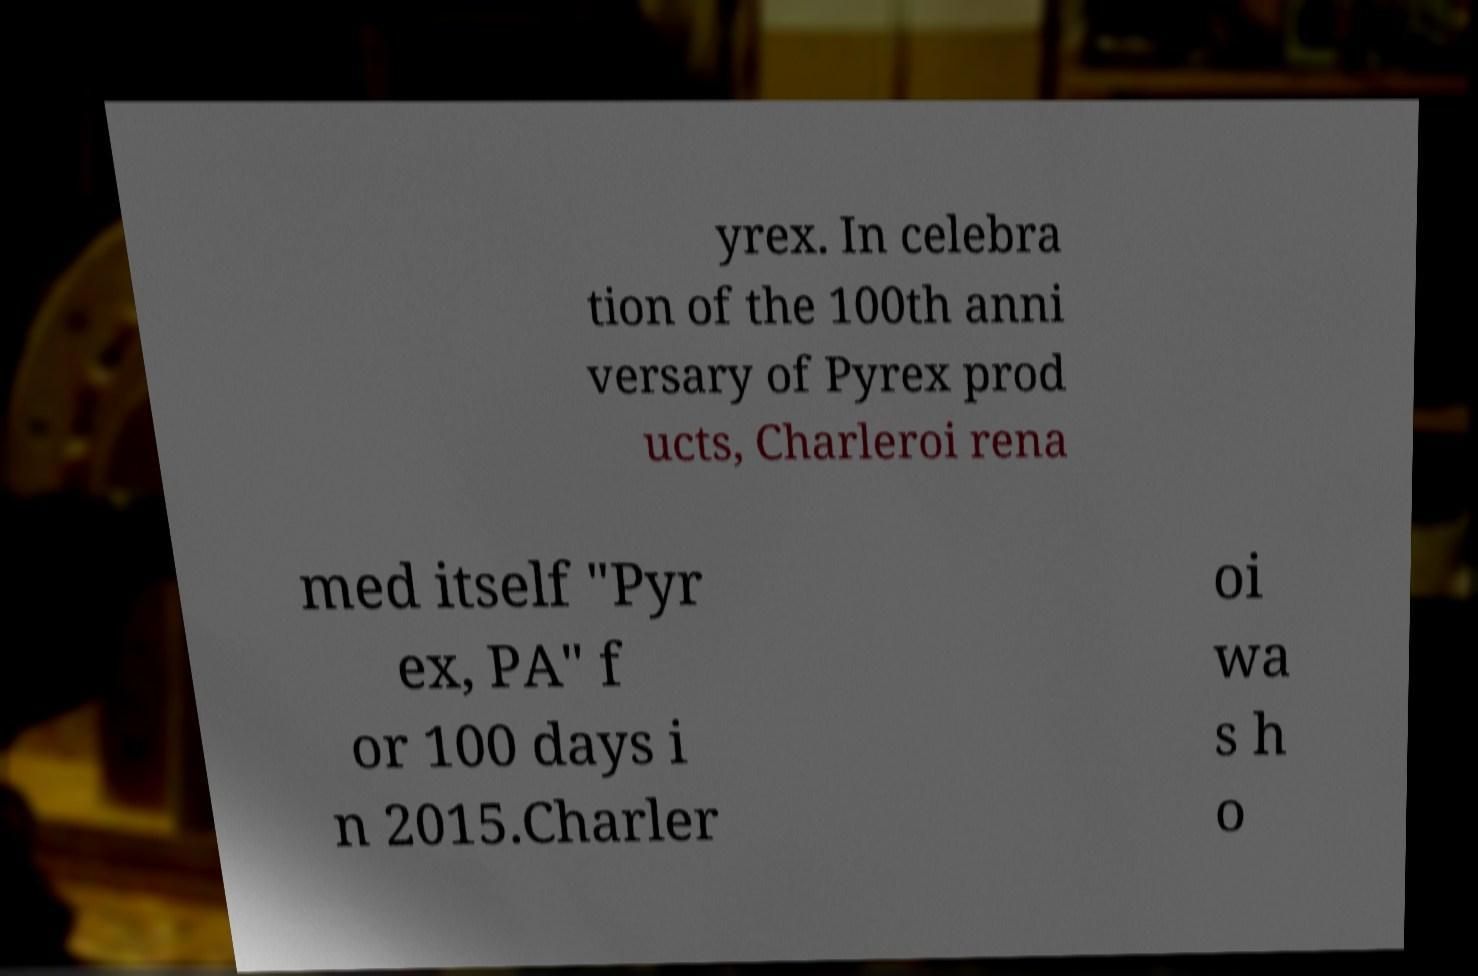What messages or text are displayed in this image? I need them in a readable, typed format. yrex. In celebra tion of the 100th anni versary of Pyrex prod ucts, Charleroi rena med itself "Pyr ex, PA" f or 100 days i n 2015.Charler oi wa s h o 